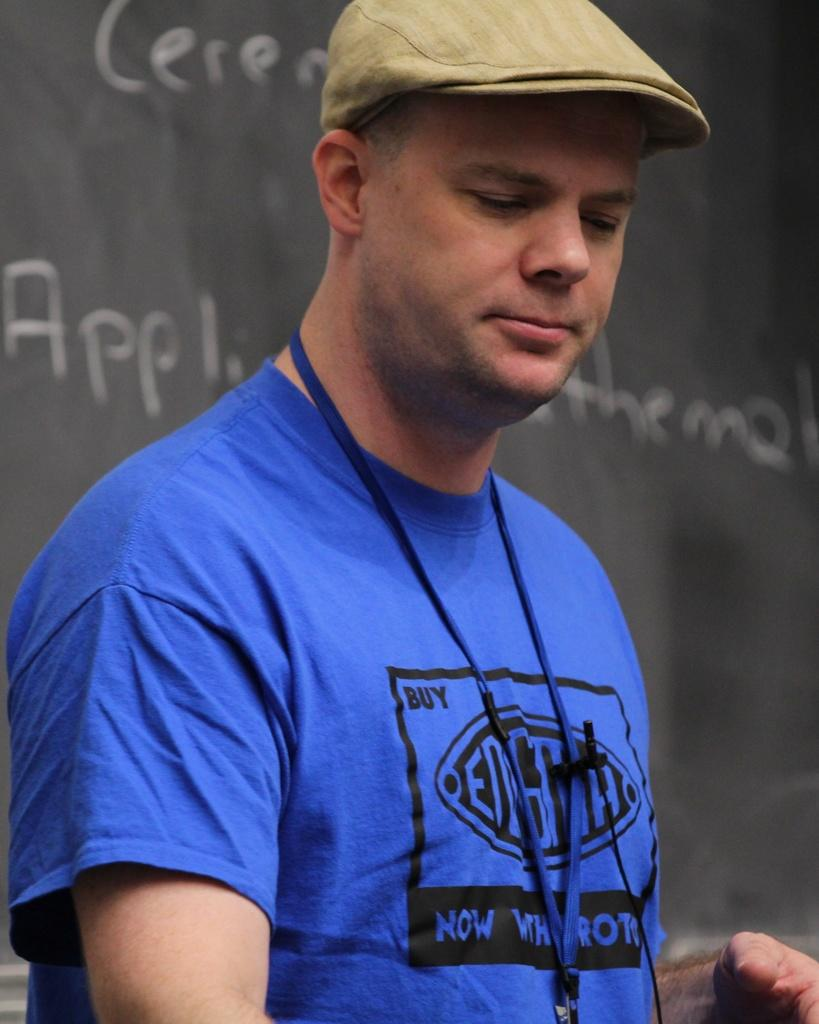<image>
Describe the image concisely. A man in a blue tee shirt which has the word BUY on it 